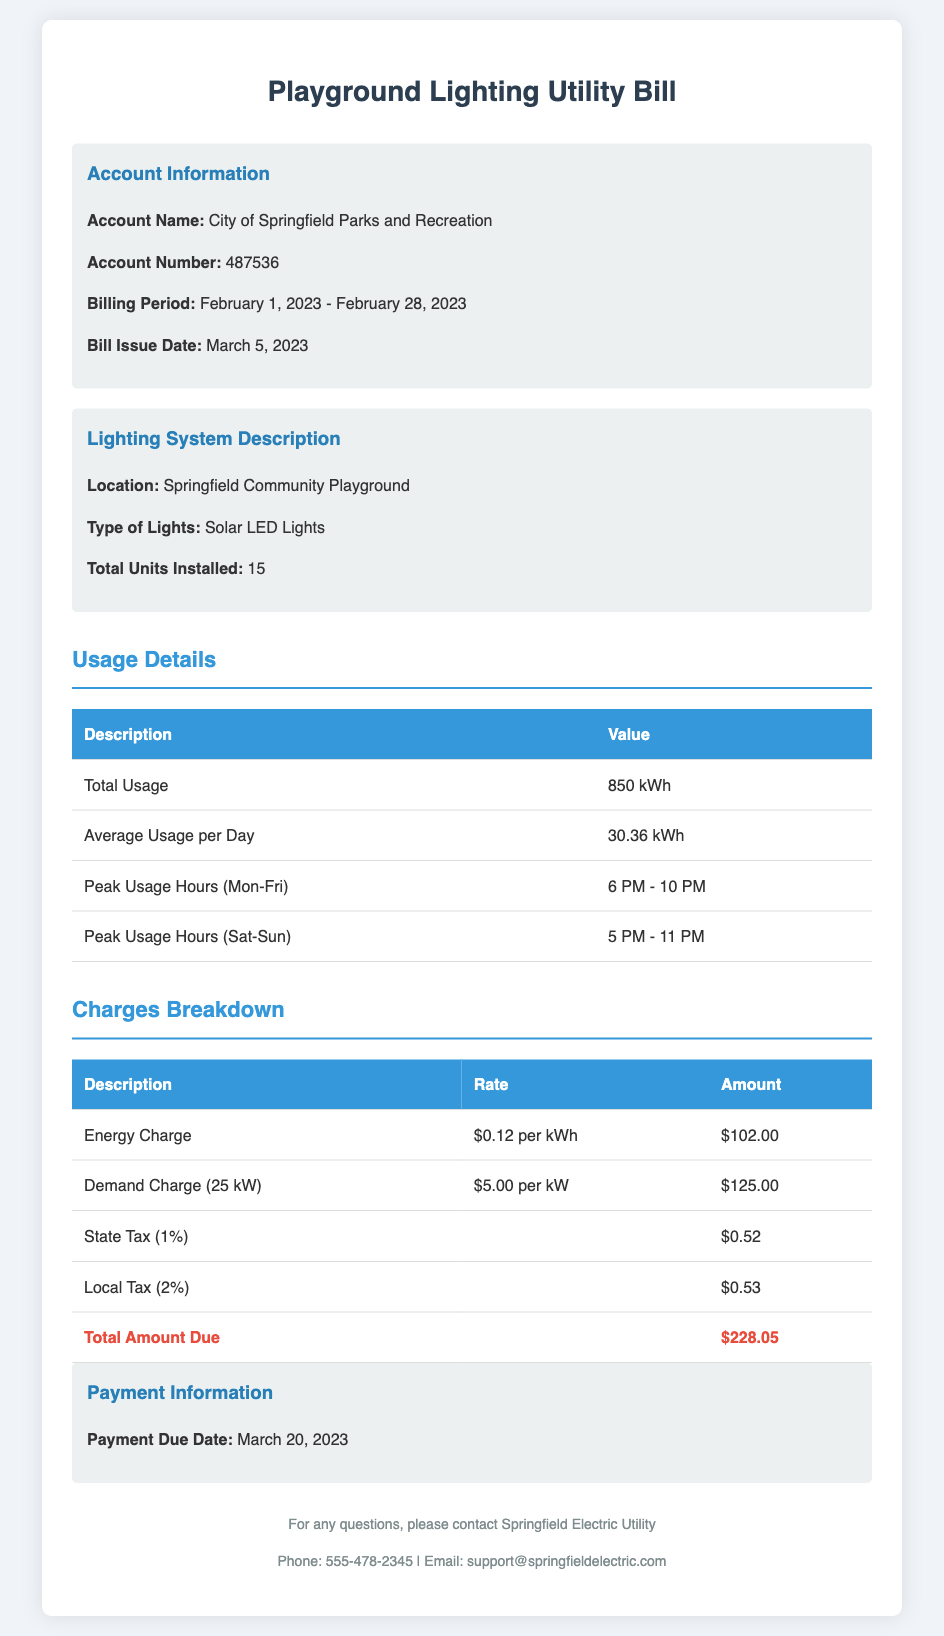What is the account name? The account name is provided in the document under Account Information.
Answer: City of Springfield Parks and Recreation What is the billing period? The billing period indicates the date range for which the bill is assessed, found in the Account Information section.
Answer: February 1, 2023 - February 28, 2023 What is the total usage? The total usage amount is listed in the Usage Details section of the document.
Answer: 850 kWh What is the energy charge rate? The energy charge rate is specified in the Charges Breakdown section.
Answer: $0.12 per kWh What is the total amount due? The total amount due is the final calculated amount indicated at the bottom of the Charges Breakdown.
Answer: $228.05 What is the payment due date? The payment due date is mentioned in the Payment Information section of the document.
Answer: March 20, 2023 How many solar LED lights are installed? The number of installed lights is found in the Lighting System Description section.
Answer: 15 What is the local tax percentage? The local tax percentage is stated in the Charges Breakdown section.
Answer: 2% What is the peak usage hours on weekends? The peak usage hours indicate the times of high usage on weekends, mentioned in the Usage Details section.
Answer: 5 PM - 11 PM 